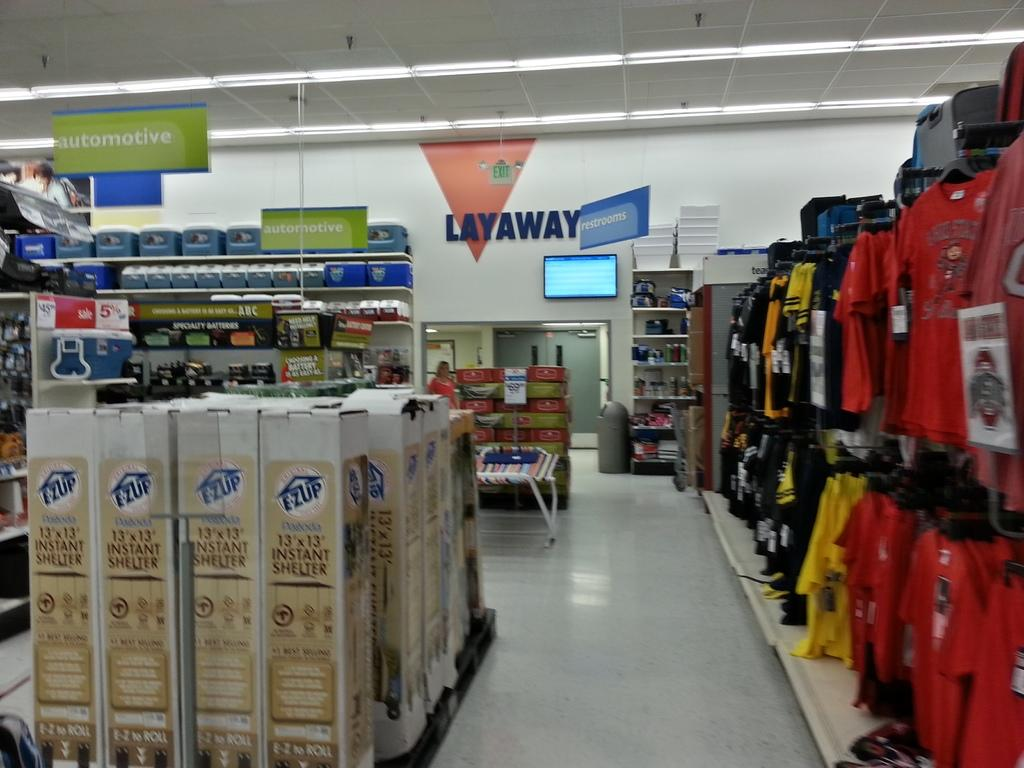What type of establishment is depicted in the image? There is a store in the image. What can be seen hanging on the hangers in the store? Clothes are hanged on hangers in the store. What type of containers are present in the store? There are cartons in the store. How are the items in the store organized or labeled? Name boards are present in the store. What type of transportation device is visible in the store? Trolleys are visible in the store. Is there a person present in the store? Yes, there is a person in the store. What type of electronic device is present in the store? A display screen is present in the store. What type of storage containers are in the store? Bins are in the store. What type of structure is visible in the store? Walls are visible in the store. How does the passenger breathe in the store? There is no passenger present in the image, so it is not possible to determine how they would breathe. 